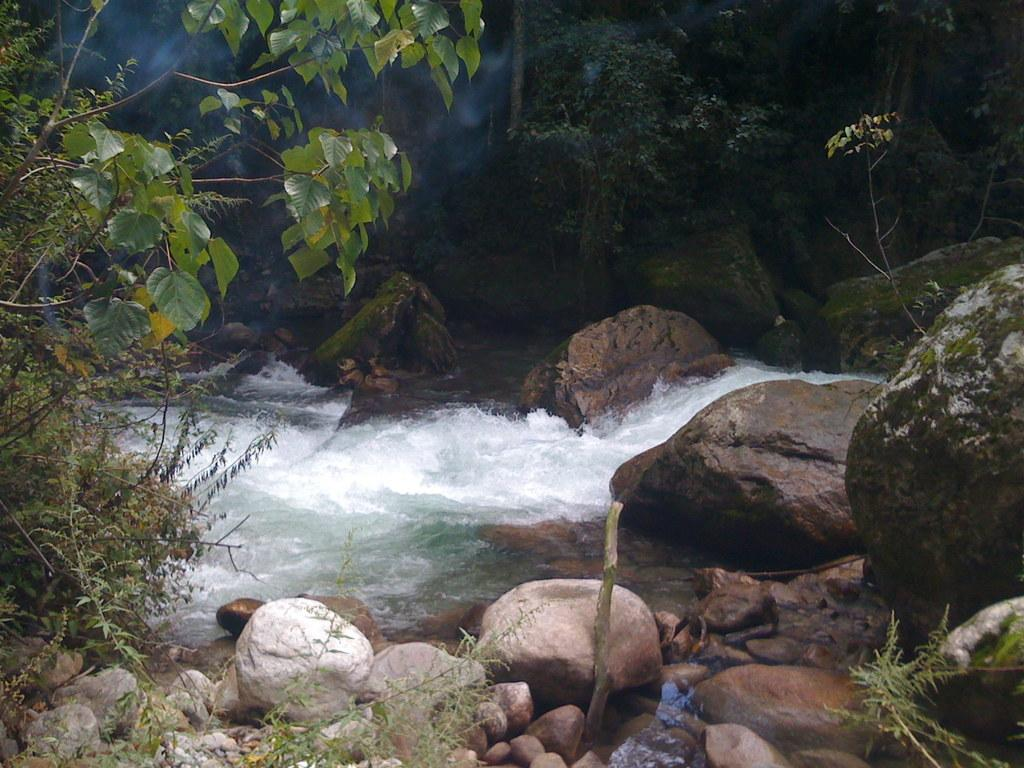What type of natural elements can be seen in the front of the image? There are rocks in the front of the image. What body of water is present in the image? There is water in the center of the image. What type of vegetation is visible in the background of the image? There are trees in the background of the image. Where is the store located in the image? There is no store present in the image. Is there a tent visible in the image? There is no tent present in the image. 